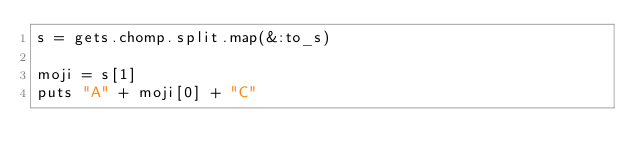<code> <loc_0><loc_0><loc_500><loc_500><_Ruby_>s = gets.chomp.split.map(&:to_s)

moji = s[1]
puts "A" + moji[0] + "C"</code> 